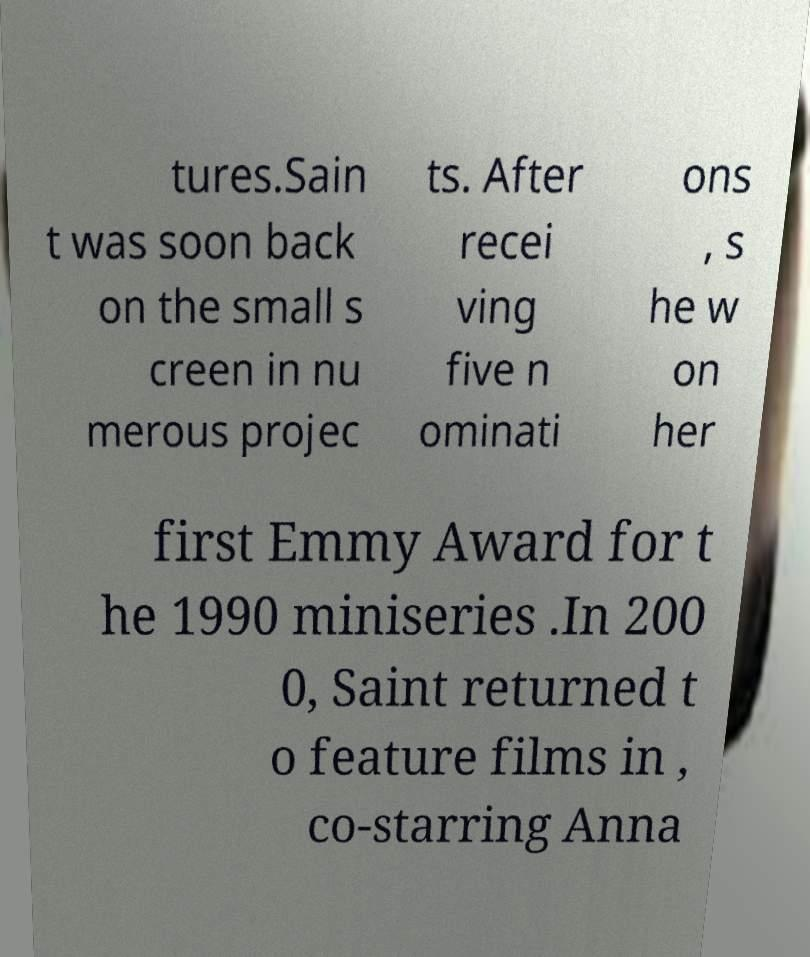I need the written content from this picture converted into text. Can you do that? tures.Sain t was soon back on the small s creen in nu merous projec ts. After recei ving five n ominati ons , s he w on her first Emmy Award for t he 1990 miniseries .In 200 0, Saint returned t o feature films in , co-starring Anna 